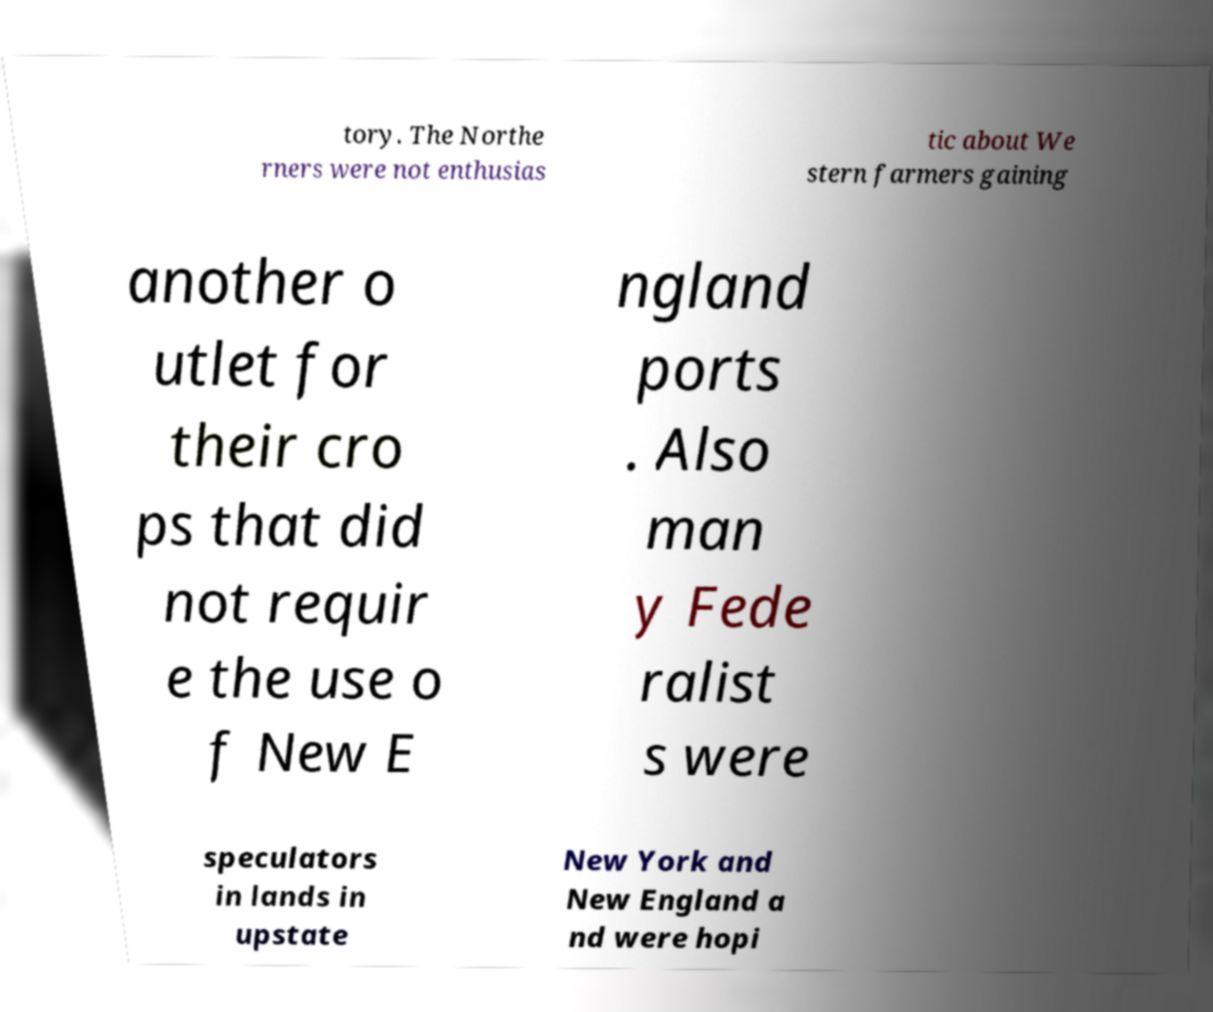Can you accurately transcribe the text from the provided image for me? tory. The Northe rners were not enthusias tic about We stern farmers gaining another o utlet for their cro ps that did not requir e the use o f New E ngland ports . Also man y Fede ralist s were speculators in lands in upstate New York and New England a nd were hopi 